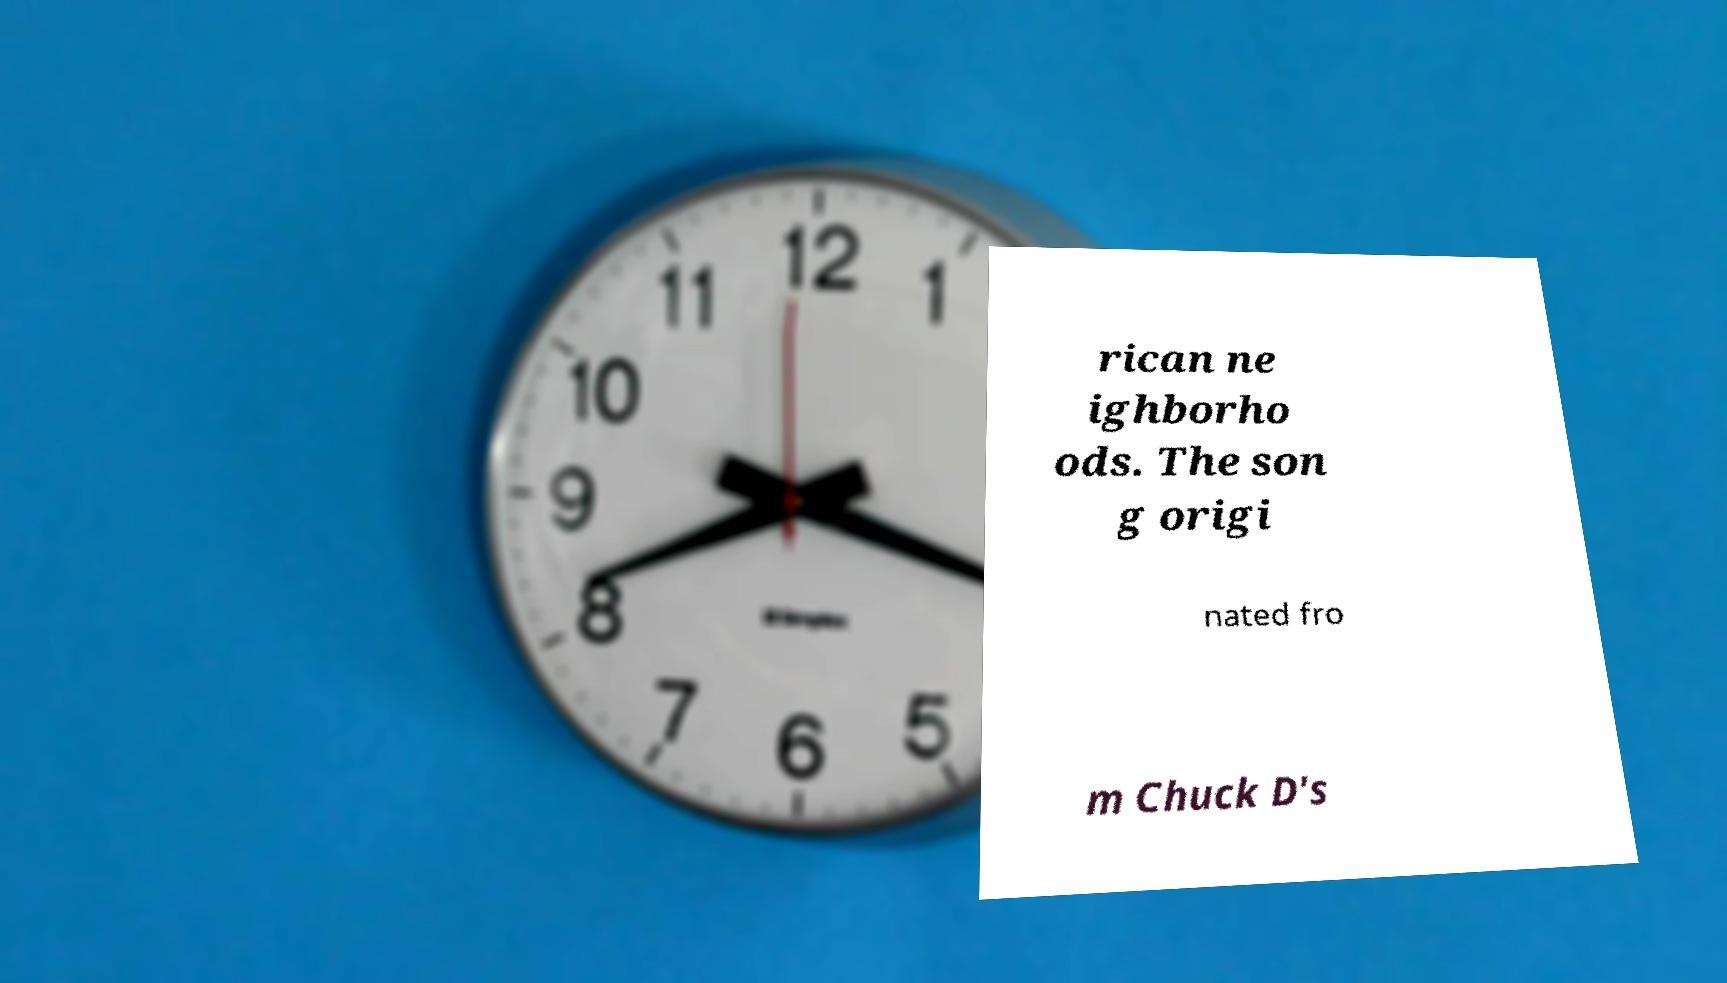Please read and relay the text visible in this image. What does it say? rican ne ighborho ods. The son g origi nated fro m Chuck D's 